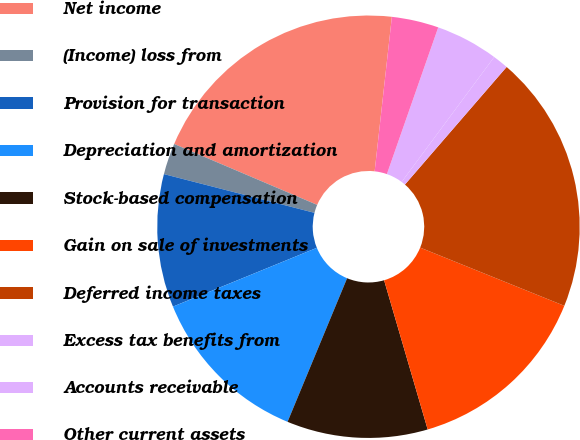Convert chart to OTSL. <chart><loc_0><loc_0><loc_500><loc_500><pie_chart><fcel>Net income<fcel>(Income) loss from<fcel>Provision for transaction<fcel>Depreciation and amortization<fcel>Stock-based compensation<fcel>Gain on sale of investments<fcel>Deferred income taxes<fcel>Excess tax benefits from<fcel>Accounts receivable<fcel>Other current assets<nl><fcel>20.36%<fcel>2.4%<fcel>10.18%<fcel>12.57%<fcel>10.78%<fcel>14.37%<fcel>19.76%<fcel>1.2%<fcel>4.79%<fcel>3.59%<nl></chart> 